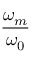<formula> <loc_0><loc_0><loc_500><loc_500>\frac { \omega _ { m } } { \omega _ { 0 } }</formula> 